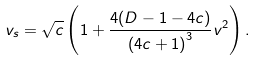<formula> <loc_0><loc_0><loc_500><loc_500>v _ { s } = \sqrt { c } \left ( 1 + \frac { 4 ( D - 1 - 4 c ) } { \left ( 4 c + 1 \right ) ^ { 3 } } v ^ { 2 } \right ) .</formula> 